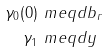<formula> <loc_0><loc_0><loc_500><loc_500>\gamma _ { 0 } ( 0 ) & \ m e q d b _ { r } \\ \gamma _ { 1 } & \ m e q d y</formula> 